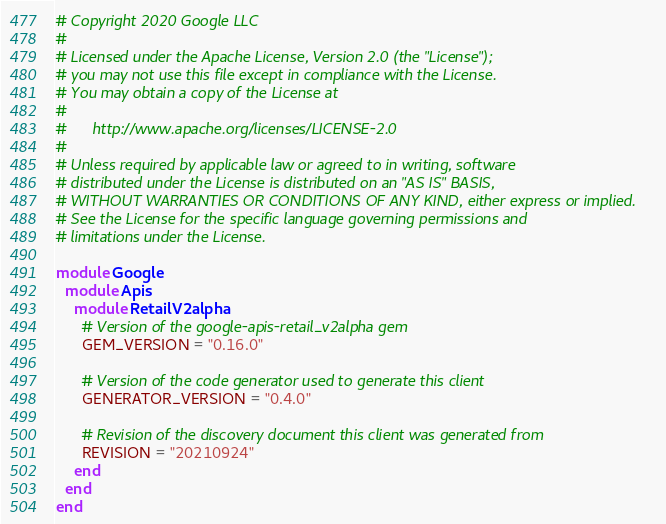Convert code to text. <code><loc_0><loc_0><loc_500><loc_500><_Ruby_># Copyright 2020 Google LLC
#
# Licensed under the Apache License, Version 2.0 (the "License");
# you may not use this file except in compliance with the License.
# You may obtain a copy of the License at
#
#      http://www.apache.org/licenses/LICENSE-2.0
#
# Unless required by applicable law or agreed to in writing, software
# distributed under the License is distributed on an "AS IS" BASIS,
# WITHOUT WARRANTIES OR CONDITIONS OF ANY KIND, either express or implied.
# See the License for the specific language governing permissions and
# limitations under the License.

module Google
  module Apis
    module RetailV2alpha
      # Version of the google-apis-retail_v2alpha gem
      GEM_VERSION = "0.16.0"

      # Version of the code generator used to generate this client
      GENERATOR_VERSION = "0.4.0"

      # Revision of the discovery document this client was generated from
      REVISION = "20210924"
    end
  end
end
</code> 